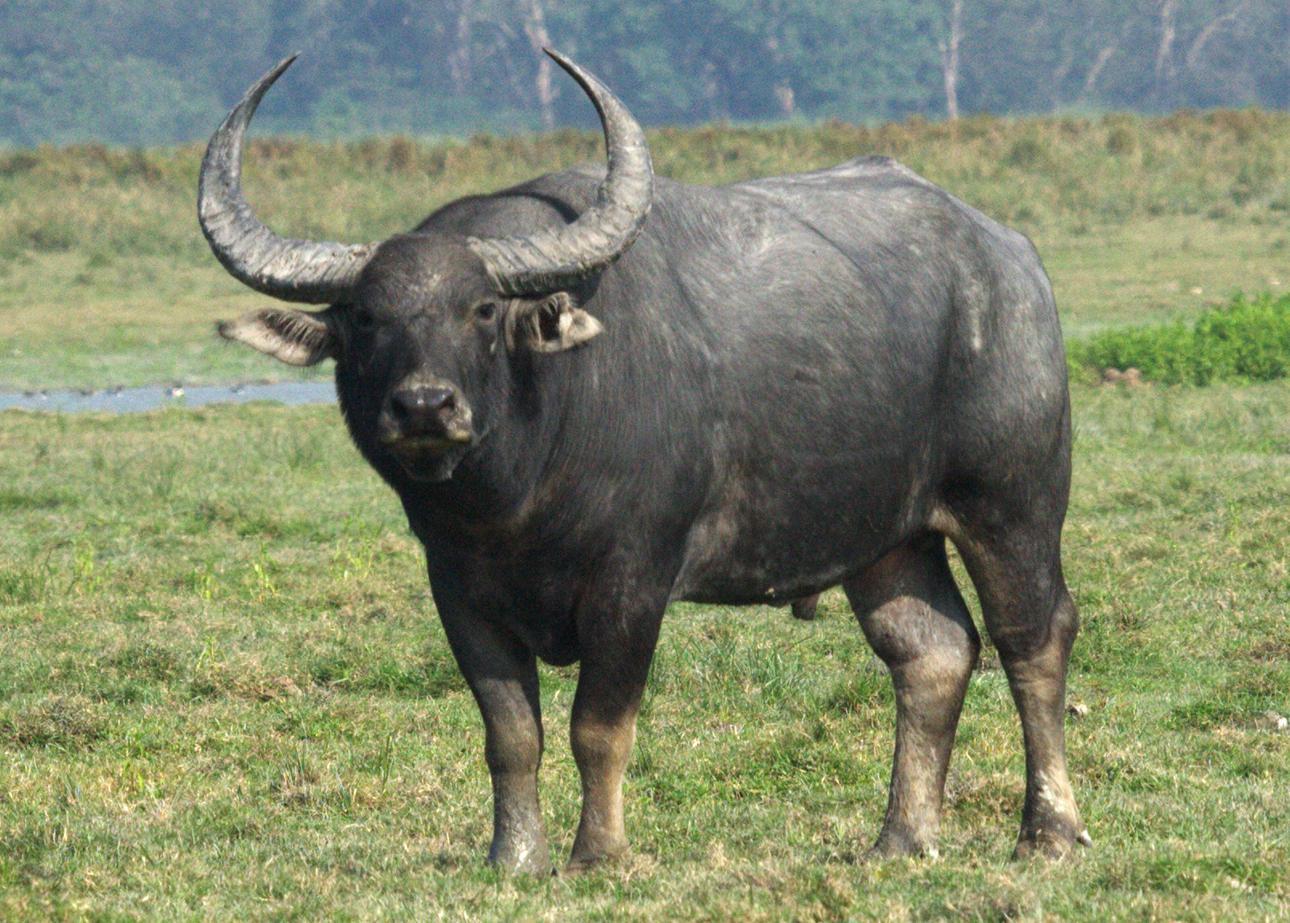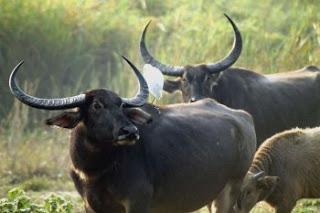The first image is the image on the left, the second image is the image on the right. Assess this claim about the two images: "The big horned cow on the left is brown and not black.". Correct or not? Answer yes or no. No. 